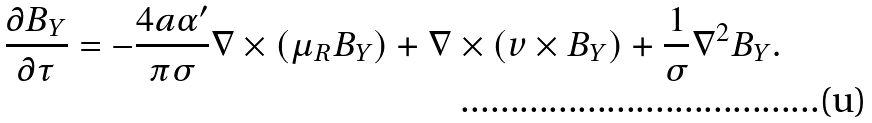<formula> <loc_0><loc_0><loc_500><loc_500>\frac { \partial { B } _ { Y } } { \partial \tau } = - \frac { 4 a \alpha ^ { \prime } } { \pi \sigma } { \nabla } \times ( \mu _ { R } { B } _ { Y } ) + { \nabla } \times ( { v } \times { B } _ { Y } ) + \frac { 1 } { \sigma } \nabla ^ { 2 } { B } _ { Y } .</formula> 